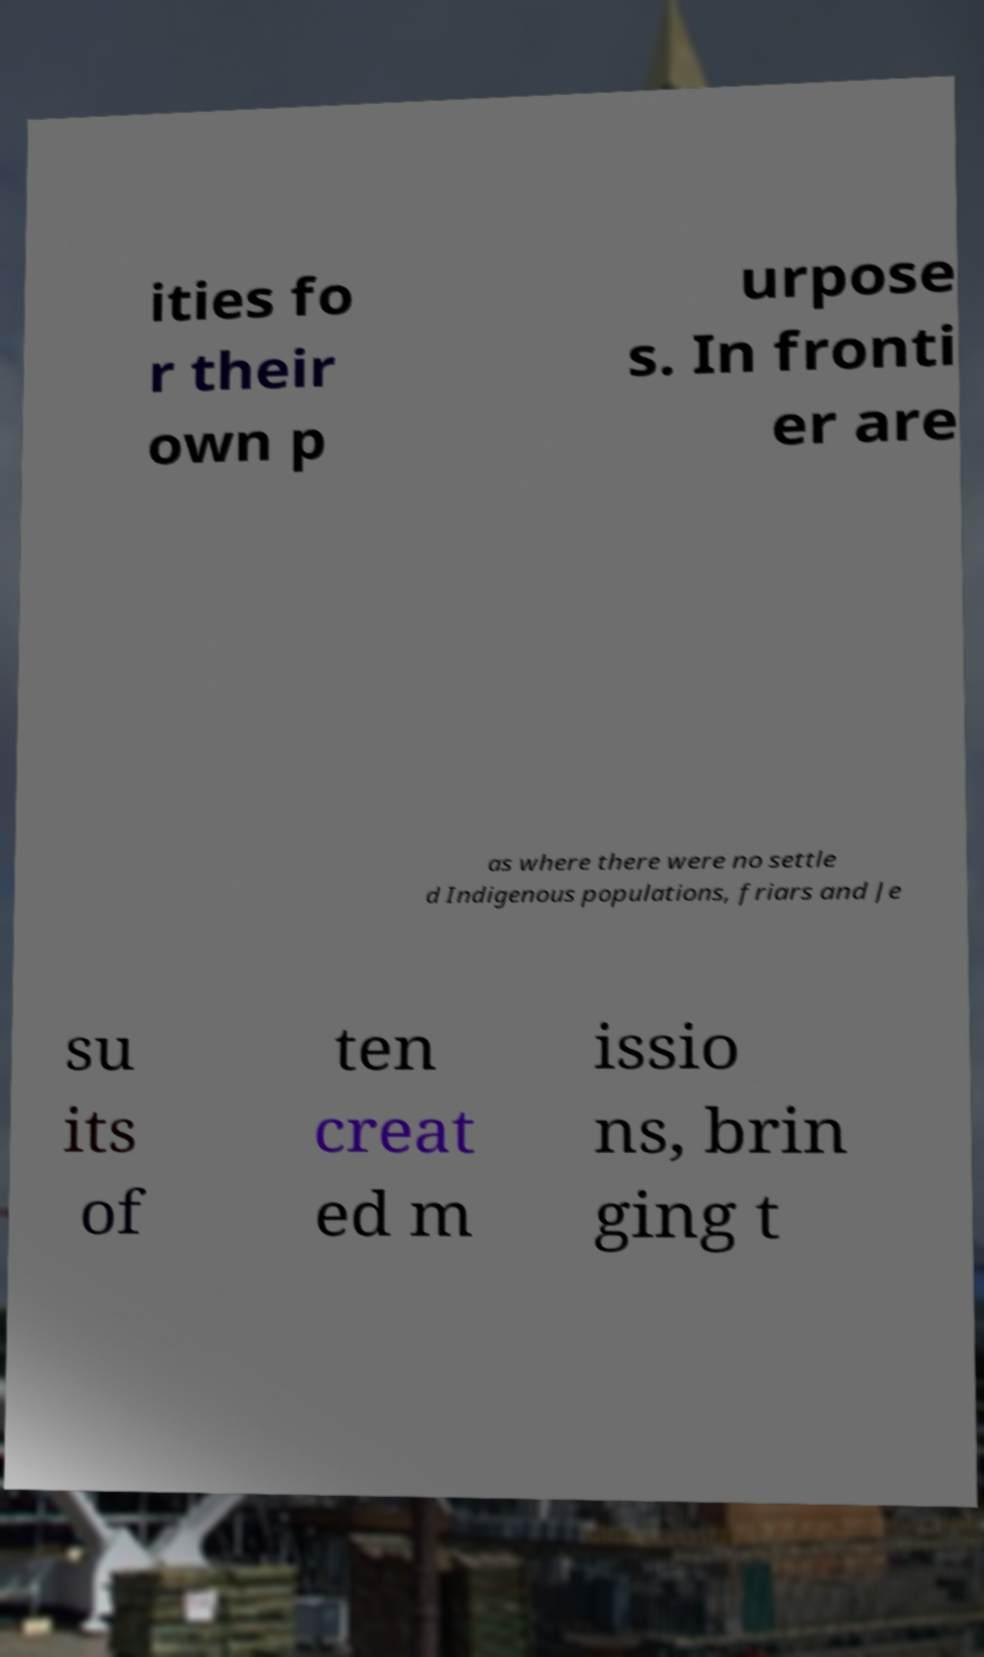Could you assist in decoding the text presented in this image and type it out clearly? ities fo r their own p urpose s. In fronti er are as where there were no settle d Indigenous populations, friars and Je su its of ten creat ed m issio ns, brin ging t 